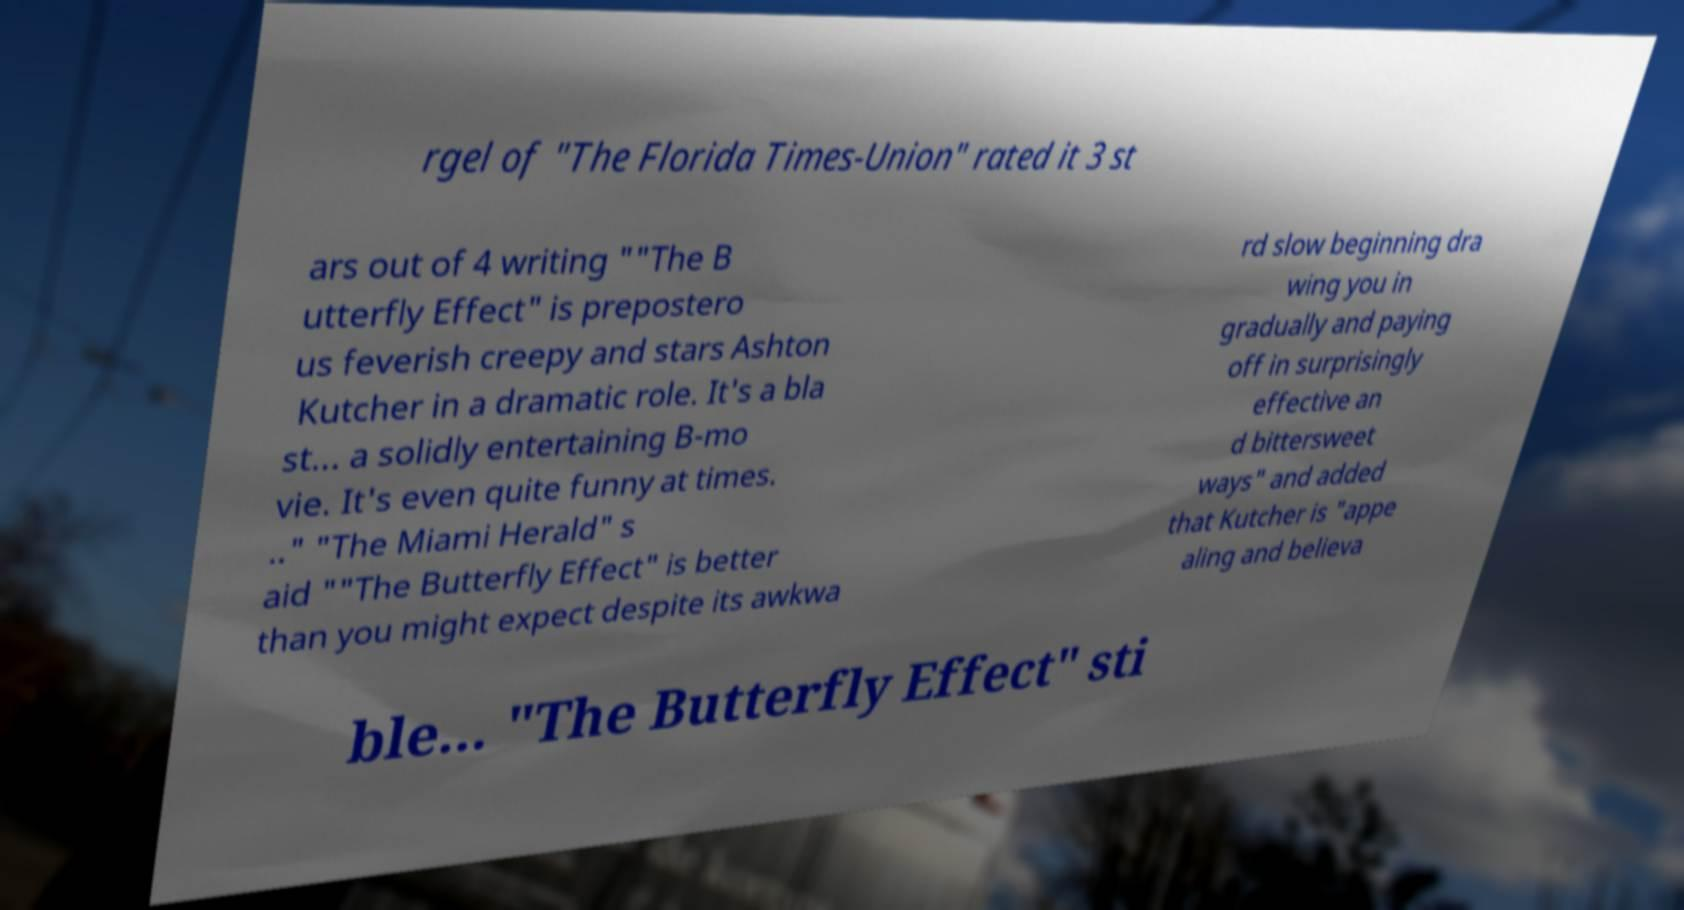Could you assist in decoding the text presented in this image and type it out clearly? rgel of "The Florida Times-Union" rated it 3 st ars out of 4 writing ""The B utterfly Effect" is prepostero us feverish creepy and stars Ashton Kutcher in a dramatic role. It's a bla st... a solidly entertaining B-mo vie. It's even quite funny at times. .." "The Miami Herald" s aid ""The Butterfly Effect" is better than you might expect despite its awkwa rd slow beginning dra wing you in gradually and paying off in surprisingly effective an d bittersweet ways" and added that Kutcher is "appe aling and believa ble... "The Butterfly Effect" sti 